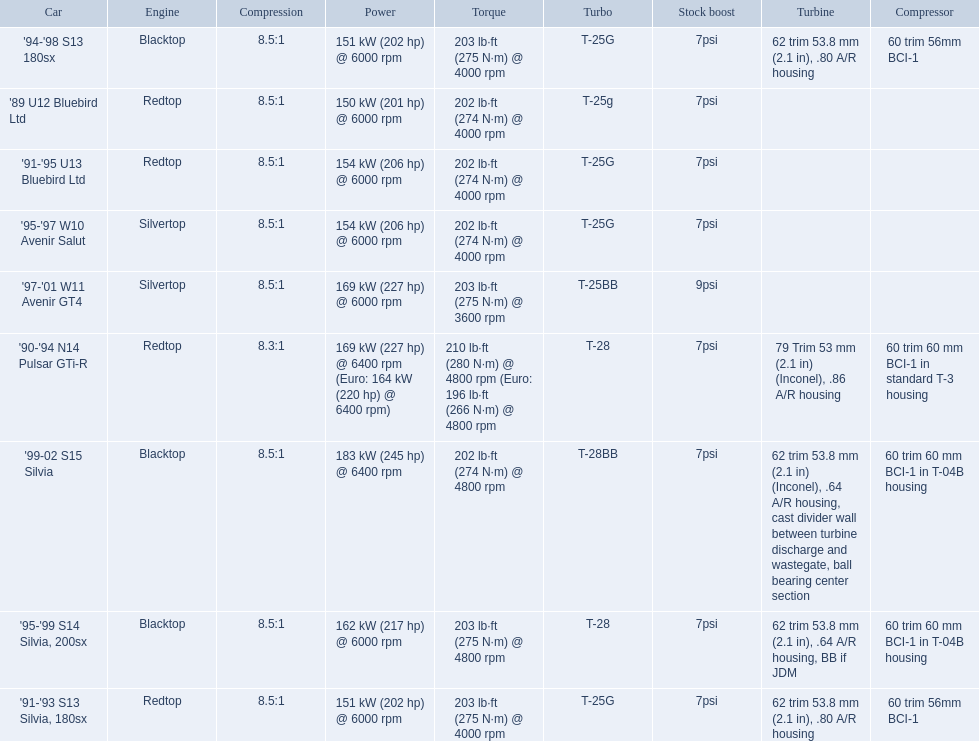What are all of the nissan cars? '89 U12 Bluebird Ltd, '91-'95 U13 Bluebird Ltd, '95-'97 W10 Avenir Salut, '97-'01 W11 Avenir GT4, '90-'94 N14 Pulsar GTi-R, '91-'93 S13 Silvia, 180sx, '94-'98 S13 180sx, '95-'99 S14 Silvia, 200sx, '99-02 S15 Silvia. Of these cars, which one is a '90-'94 n14 pulsar gti-r? '90-'94 N14 Pulsar GTi-R. What is the compression of this car? 8.3:1. What cars are there? '89 U12 Bluebird Ltd, 7psi, '91-'95 U13 Bluebird Ltd, 7psi, '95-'97 W10 Avenir Salut, 7psi, '97-'01 W11 Avenir GT4, 9psi, '90-'94 N14 Pulsar GTi-R, 7psi, '91-'93 S13 Silvia, 180sx, 7psi, '94-'98 S13 180sx, 7psi, '95-'99 S14 Silvia, 200sx, 7psi, '99-02 S15 Silvia, 7psi. Which stock boost is over 7psi? '97-'01 W11 Avenir GT4, 9psi. What car is it? '97-'01 W11 Avenir GT4. 